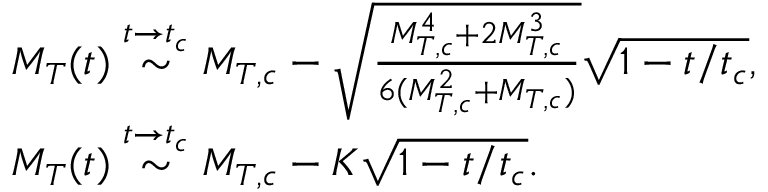Convert formula to latex. <formula><loc_0><loc_0><loc_500><loc_500>\begin{array} { r l } & { M _ { T } ( t ) \stackrel { t \rightarrow t _ { c } } { \sim } M _ { T , c } - \sqrt { \frac { M _ { T , c } ^ { 4 } + 2 M _ { T , c } ^ { 3 } } { 6 ( M _ { T , c } ^ { 2 } + M _ { T , c } ) } } \sqrt { 1 - t / t _ { c } } , } \\ & { M _ { T } ( t ) \stackrel { t \rightarrow t _ { c } } { \sim } M _ { T , c } - K \sqrt { 1 - t / t _ { c } } . } \end{array}</formula> 